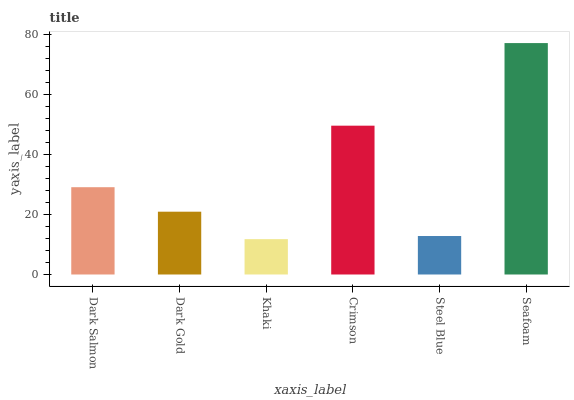Is Khaki the minimum?
Answer yes or no. Yes. Is Seafoam the maximum?
Answer yes or no. Yes. Is Dark Gold the minimum?
Answer yes or no. No. Is Dark Gold the maximum?
Answer yes or no. No. Is Dark Salmon greater than Dark Gold?
Answer yes or no. Yes. Is Dark Gold less than Dark Salmon?
Answer yes or no. Yes. Is Dark Gold greater than Dark Salmon?
Answer yes or no. No. Is Dark Salmon less than Dark Gold?
Answer yes or no. No. Is Dark Salmon the high median?
Answer yes or no. Yes. Is Dark Gold the low median?
Answer yes or no. Yes. Is Khaki the high median?
Answer yes or no. No. Is Crimson the low median?
Answer yes or no. No. 